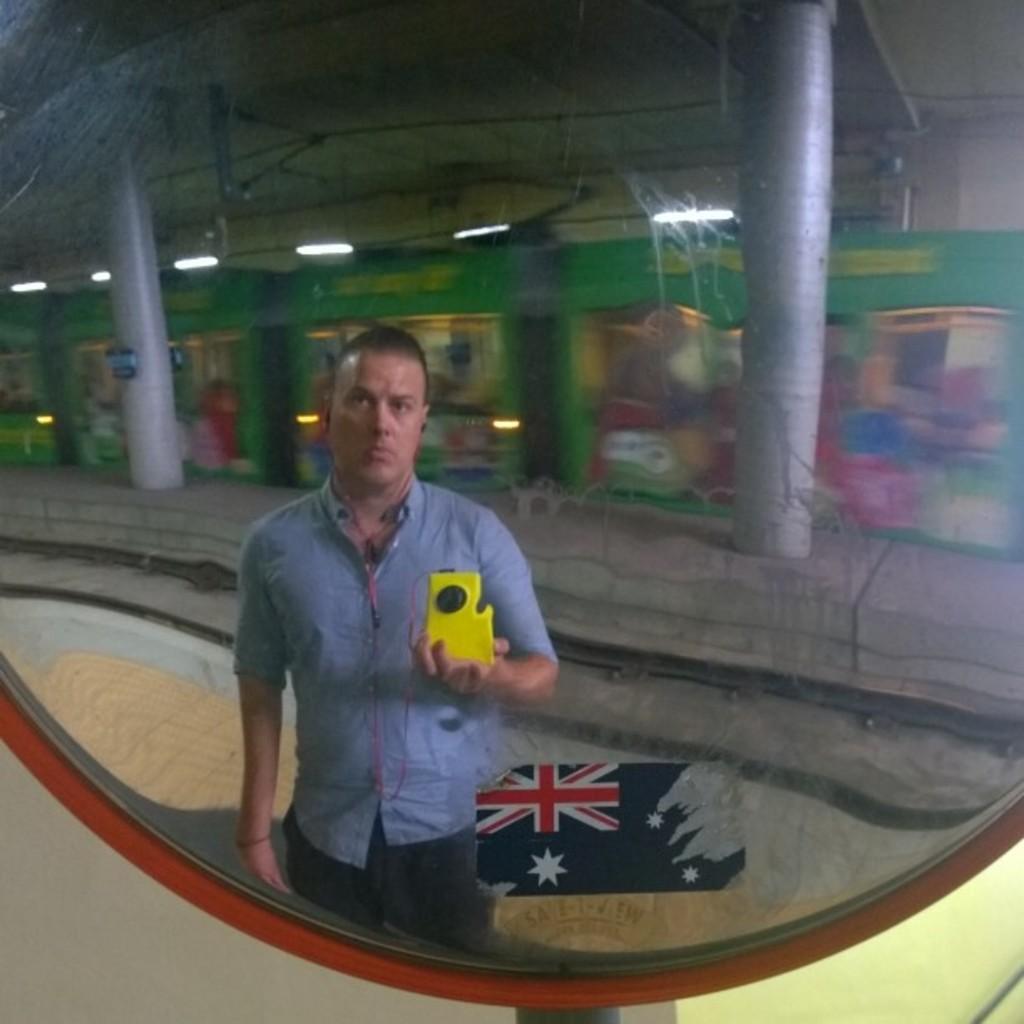Can you describe this image briefly? In this picture we can observe a mirror. In the mirror we can observe a person standing on the platform. There is a railway track behind him. In the background we can observe two pillars and some tube lights fixed to the wall. 